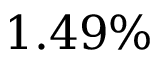<formula> <loc_0><loc_0><loc_500><loc_500>1 . 4 9 \%</formula> 